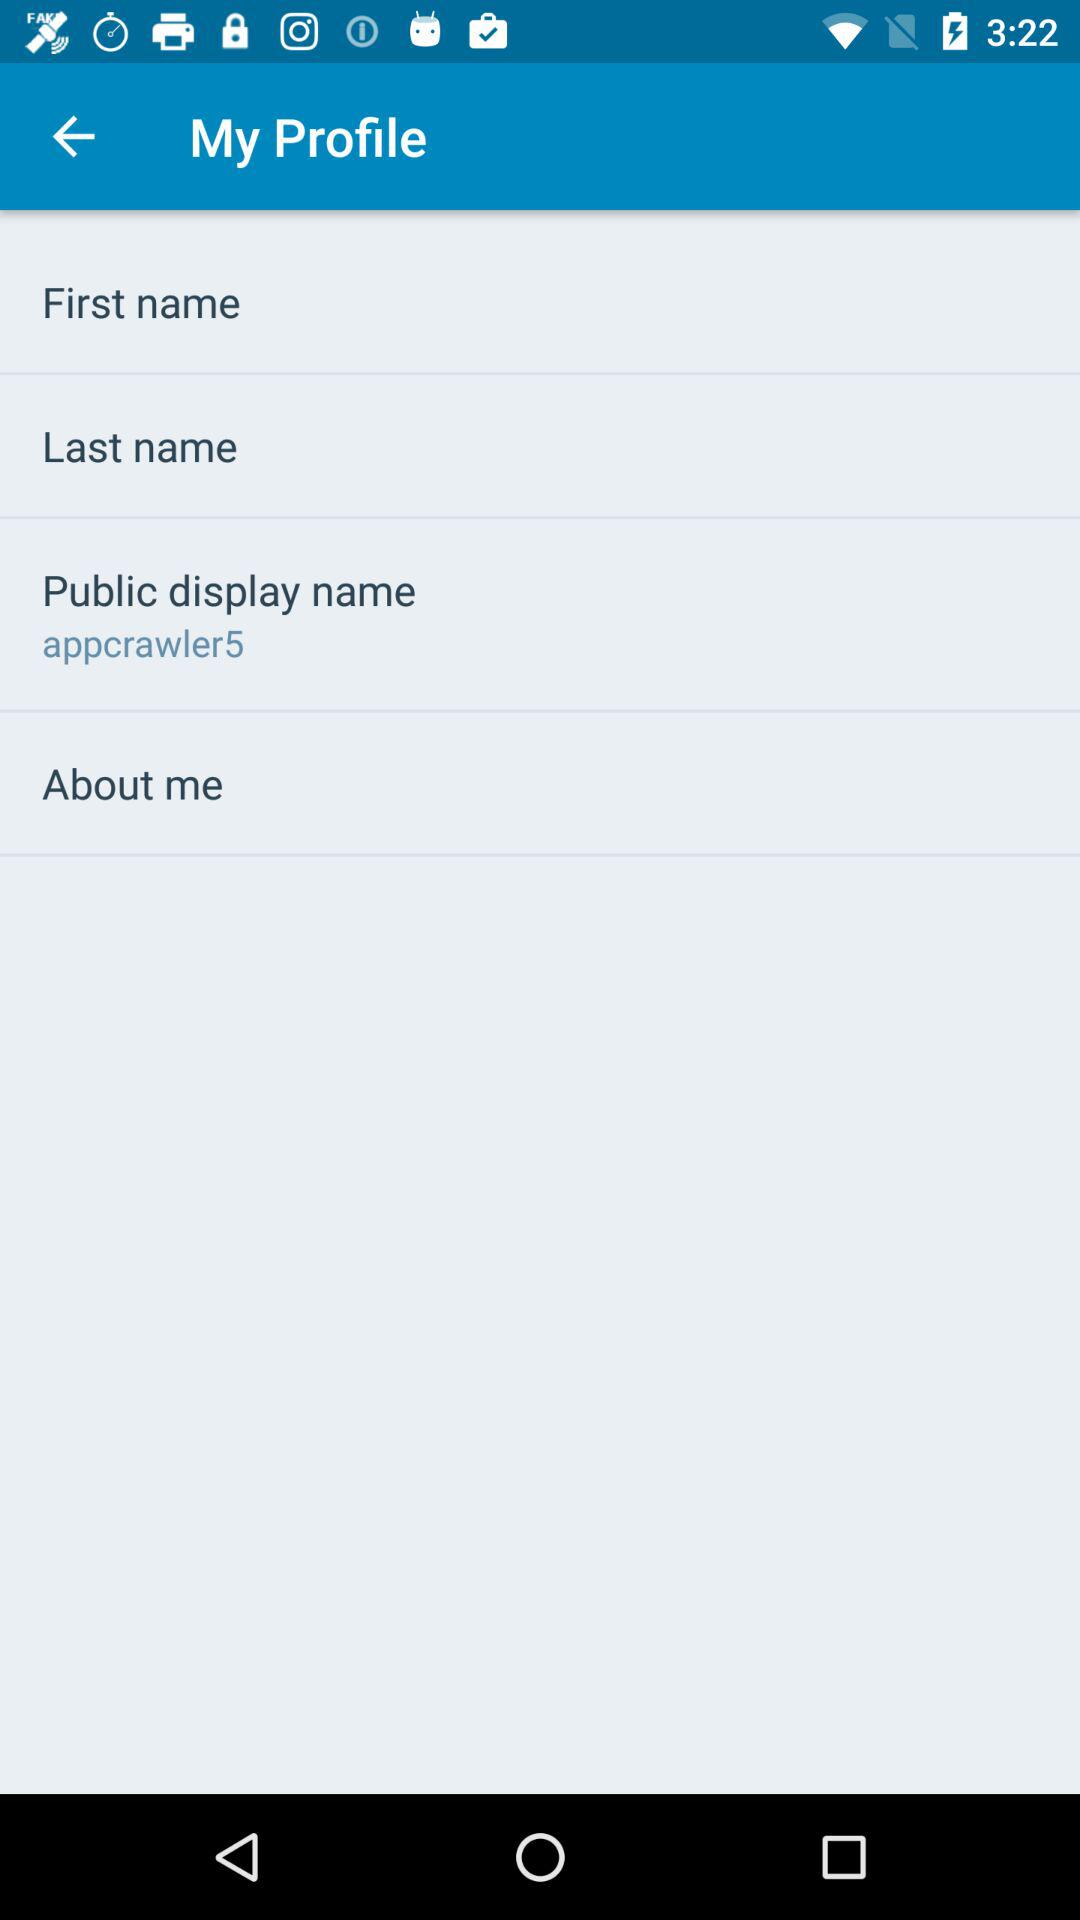What is the "Public display name"? The "Public display name" is Appcrawler5. 